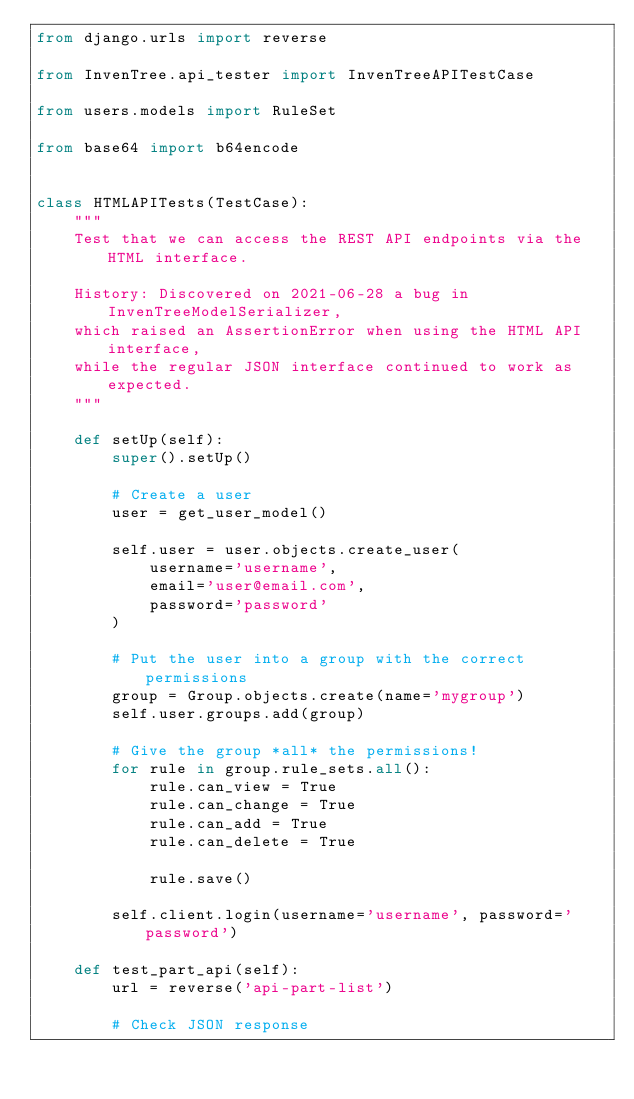<code> <loc_0><loc_0><loc_500><loc_500><_Python_>from django.urls import reverse

from InvenTree.api_tester import InvenTreeAPITestCase

from users.models import RuleSet

from base64 import b64encode


class HTMLAPITests(TestCase):
    """
    Test that we can access the REST API endpoints via the HTML interface.
    
    History: Discovered on 2021-06-28 a bug in InvenTreeModelSerializer,
    which raised an AssertionError when using the HTML API interface,
    while the regular JSON interface continued to work as expected.
    """

    def setUp(self):
        super().setUp()

        # Create a user
        user = get_user_model()

        self.user = user.objects.create_user(
            username='username',
            email='user@email.com',
            password='password'
        )

        # Put the user into a group with the correct permissions
        group = Group.objects.create(name='mygroup')
        self.user.groups.add(group)

        # Give the group *all* the permissions!
        for rule in group.rule_sets.all():
            rule.can_view = True
            rule.can_change = True
            rule.can_add = True
            rule.can_delete = True

            rule.save()

        self.client.login(username='username', password='password')

    def test_part_api(self):
        url = reverse('api-part-list')

        # Check JSON response</code> 